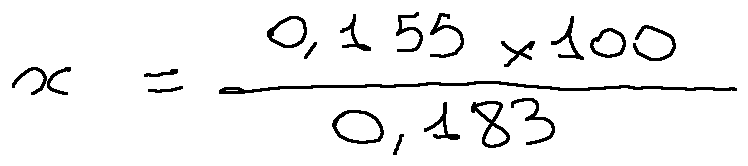<formula> <loc_0><loc_0><loc_500><loc_500>x = \frac { 0 , 1 5 5 \times 1 0 0 } { 0 , 1 8 3 }</formula> 